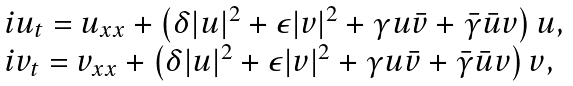Convert formula to latex. <formula><loc_0><loc_0><loc_500><loc_500>\begin{array} { l l } i u _ { t } = u _ { x x } + \left ( \delta | u | ^ { 2 } + \epsilon | v | ^ { 2 } + \gamma u \bar { v } + \bar { \gamma } \bar { u } v \right ) u , \\ i v _ { t } = v _ { x x } + \left ( \delta | u | ^ { 2 } + \epsilon | v | ^ { 2 } + \gamma u \bar { v } + \bar { \gamma } \bar { u } v \right ) v , \end{array}</formula> 